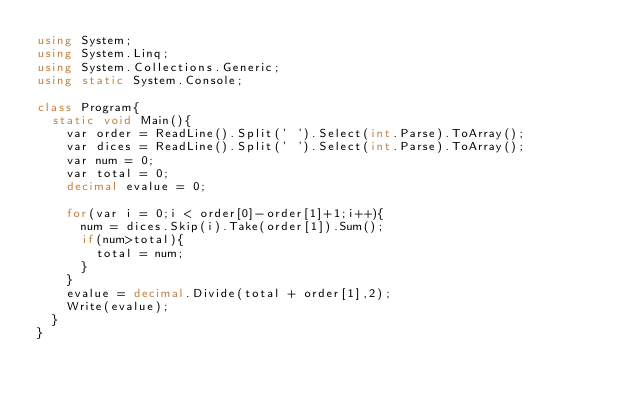<code> <loc_0><loc_0><loc_500><loc_500><_C#_>using System;
using System.Linq;
using System.Collections.Generic;
using static System.Console;

class Program{
  static void Main(){
	var order = ReadLine().Split(' ').Select(int.Parse).ToArray();
    var dices = ReadLine().Split(' ').Select(int.Parse).ToArray();
    var num = 0;
    var total = 0;
    decimal evalue = 0;
    
    for(var i = 0;i < order[0]-order[1]+1;i++){
      num = dices.Skip(i).Take(order[1]).Sum();
      if(num>total){
        total = num;
      }
    }
    evalue = decimal.Divide(total + order[1],2);
    Write(evalue);
  }
}

</code> 